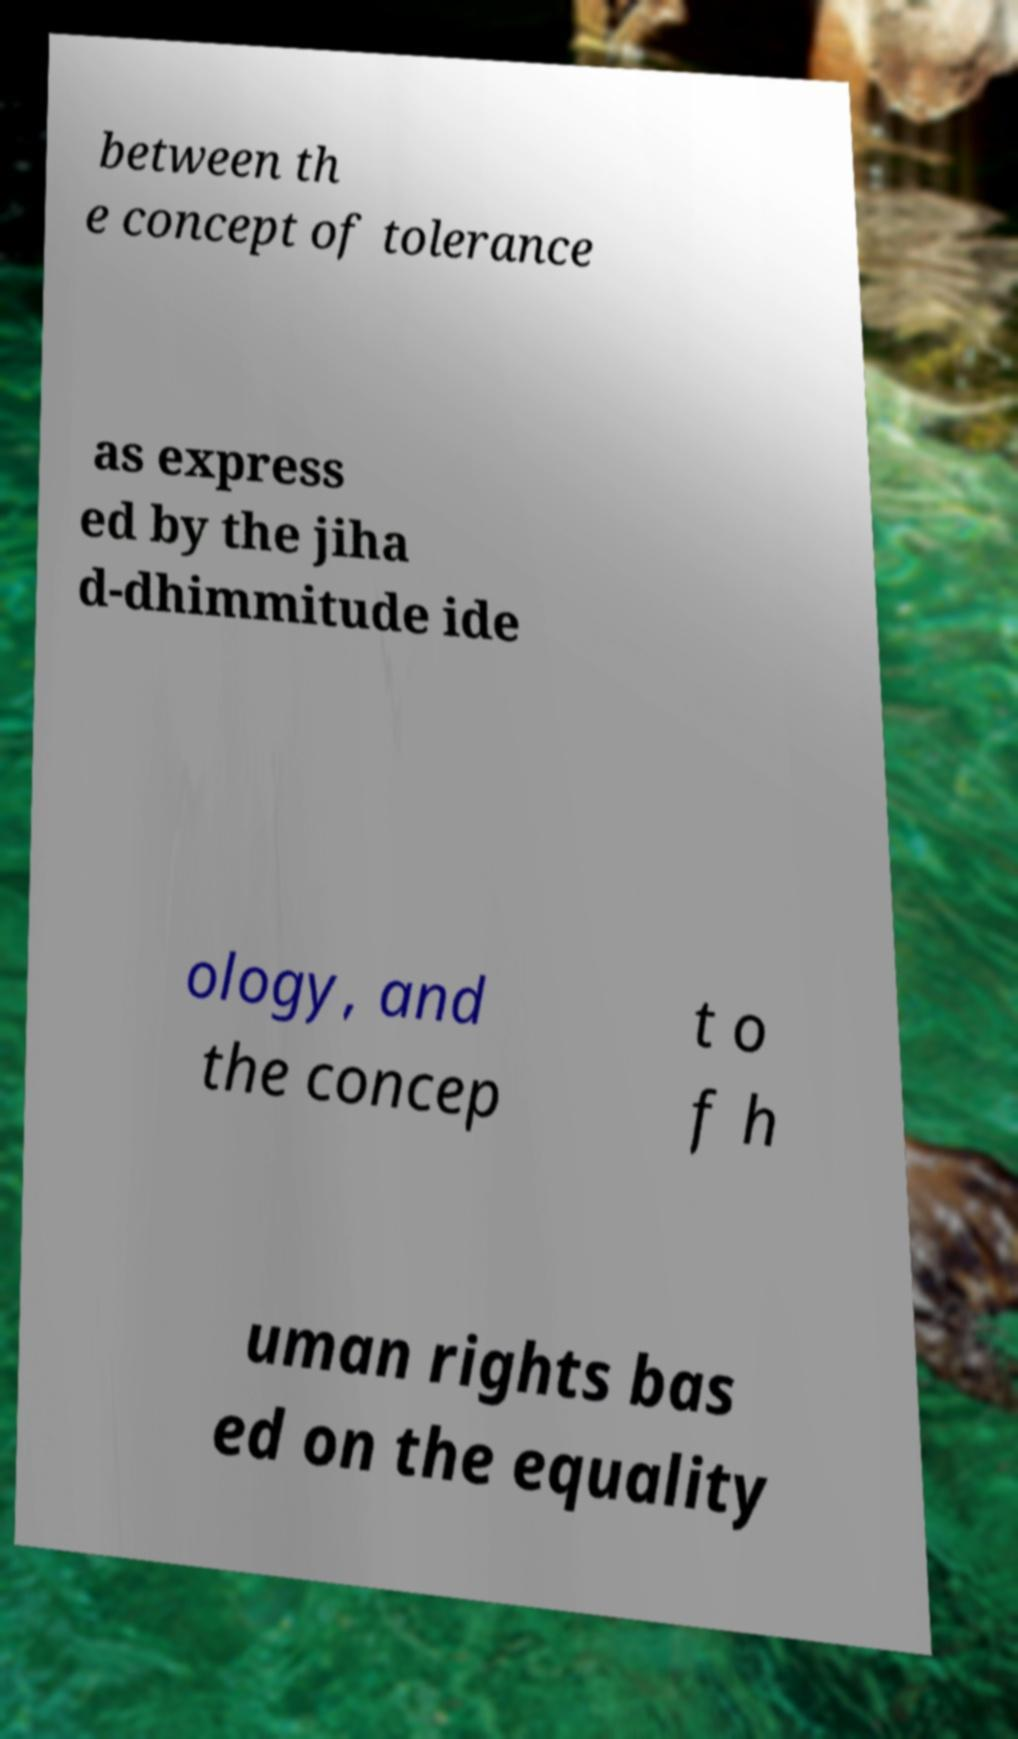Could you assist in decoding the text presented in this image and type it out clearly? between th e concept of tolerance as express ed by the jiha d-dhimmitude ide ology, and the concep t o f h uman rights bas ed on the equality 